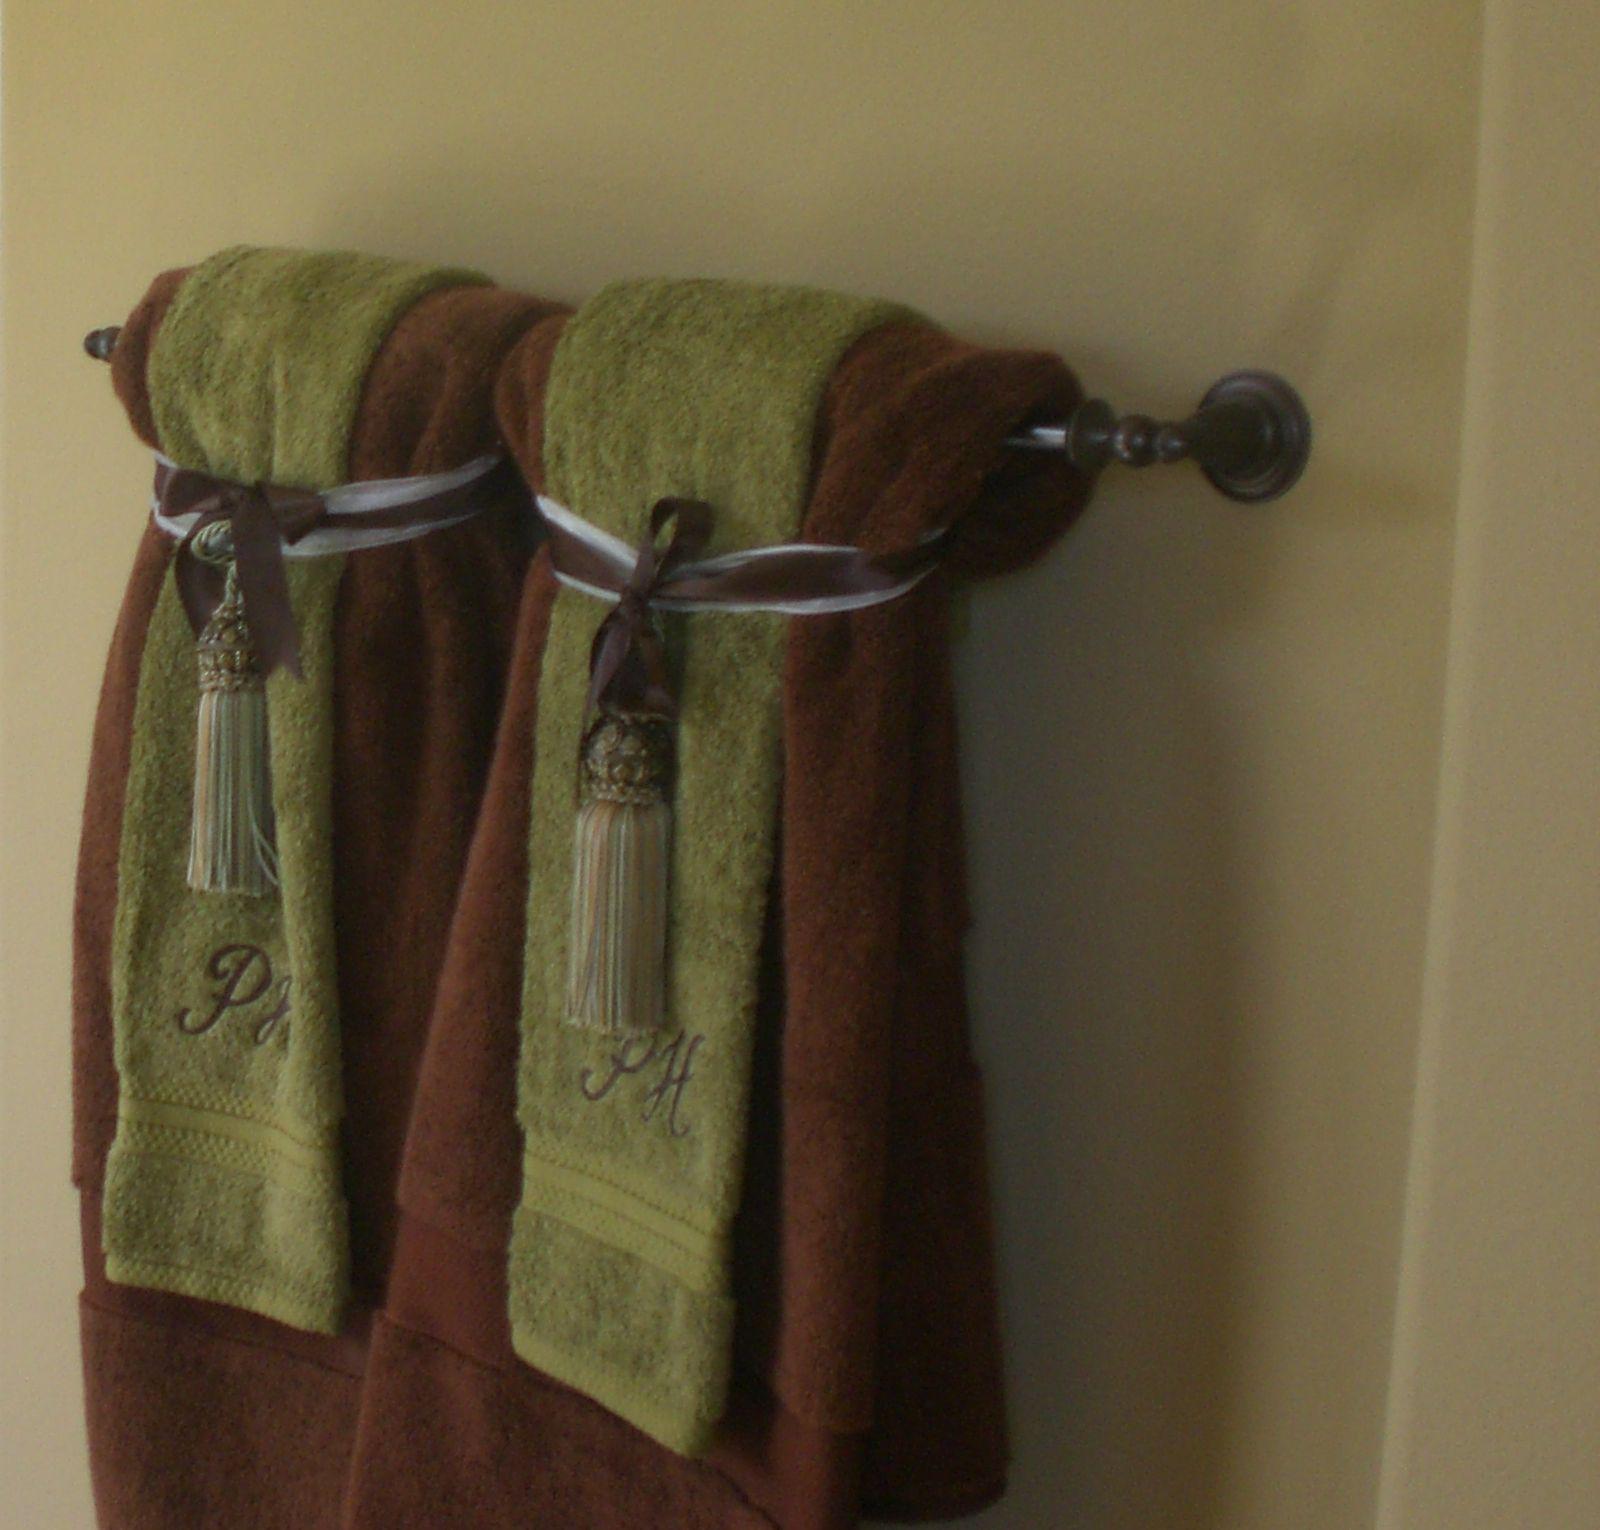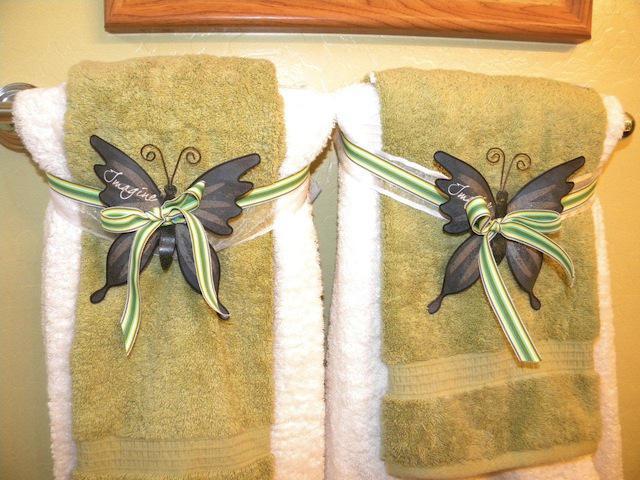The first image is the image on the left, the second image is the image on the right. For the images shown, is this caption "One of the blue towels is folded into a fan shape on the top part." true? Answer yes or no. No. The first image is the image on the left, the second image is the image on the right. For the images shown, is this caption "There are blue towels." true? Answer yes or no. No. 